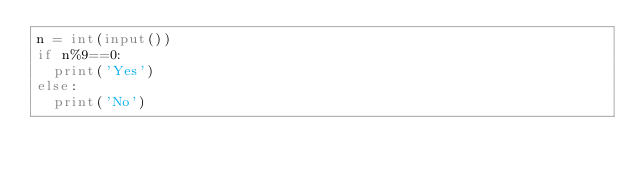<code> <loc_0><loc_0><loc_500><loc_500><_Python_>n = int(input())
if n%9==0:
  print('Yes')
else:
  print('No')</code> 